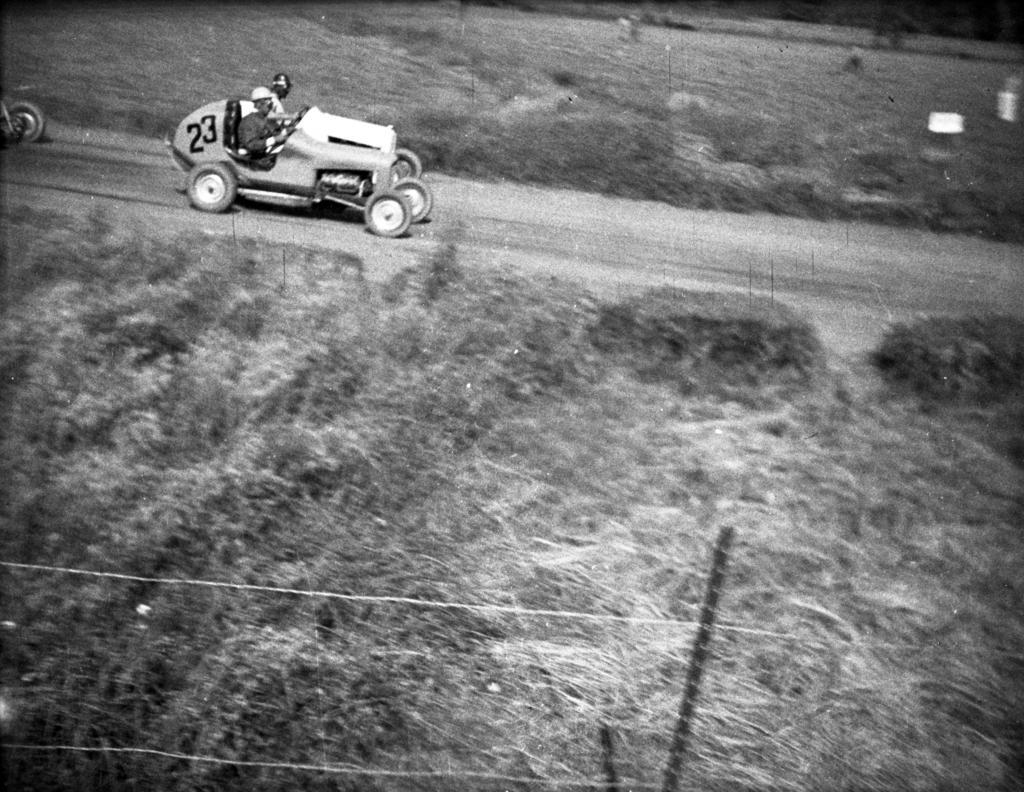Please provide a concise description of this image. In this image I can see a pole, few wires, few vehicles and in these vehicles I can see two persons are sitting. I can also see few numbers are written over here. 